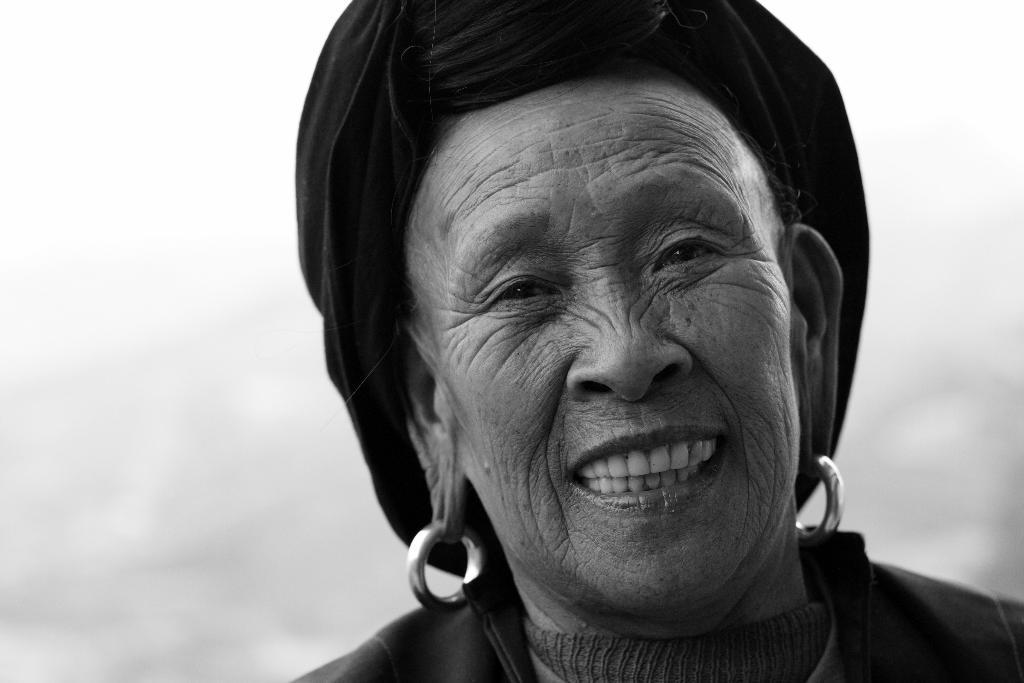Please provide a concise description of this image. In this image I can see a person face and I can see sky, and the image is in black and white. 